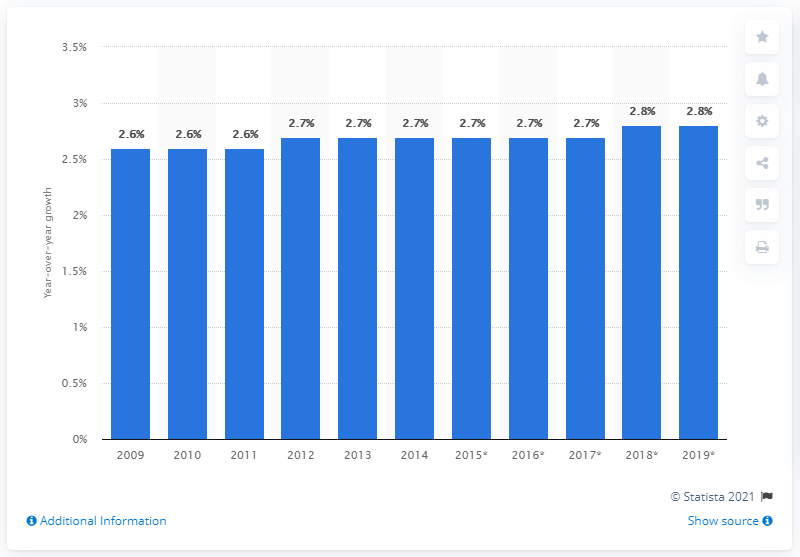Outline some significant characteristics in this image. In 2014, the market value of artisanal ice cream in Canada increased by 2.6 percent. The market value of artisanal ice cream in Canada in 2009 was approximately CAD 2.6 billion. 